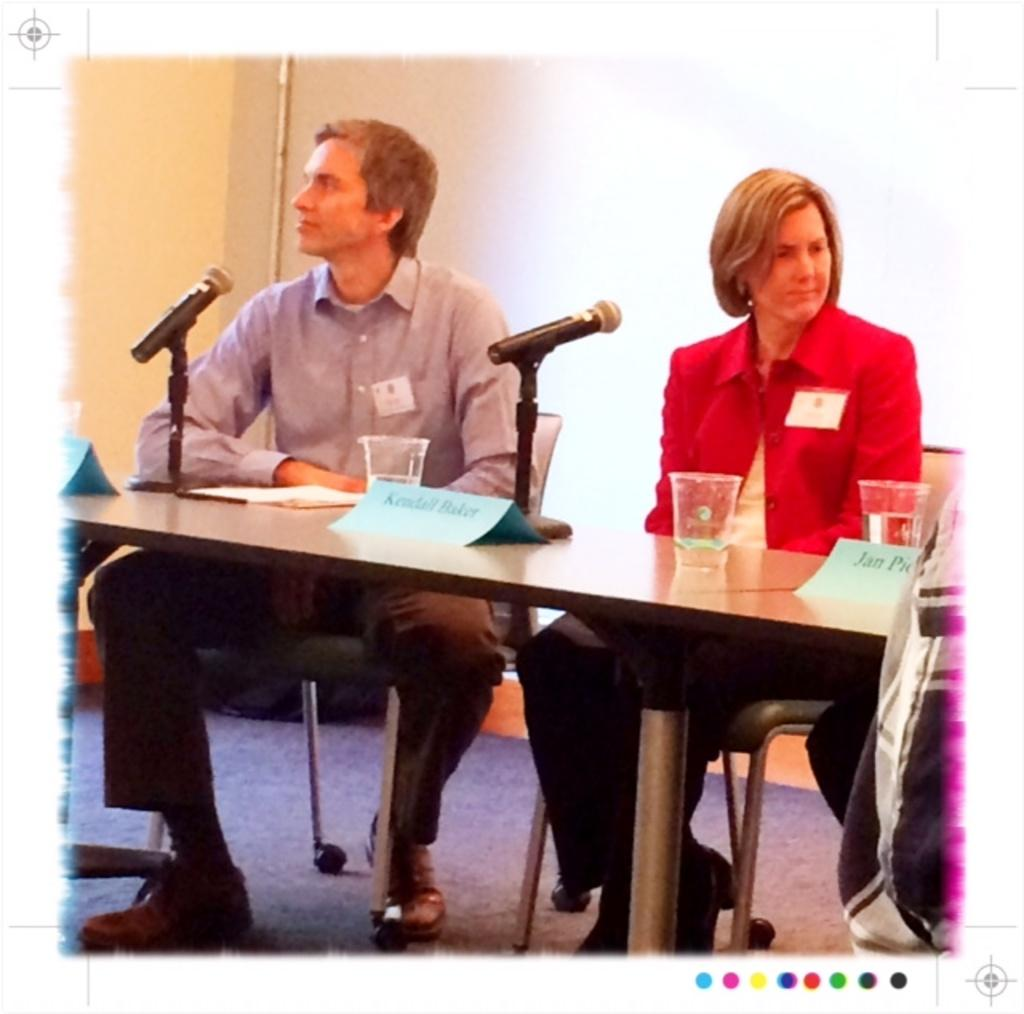Who can be seen in the image? There is a man and a woman in the image. What are the man and the woman doing in the image? They are seated on chairs and speaking using a microphone. What is present on the table in the image? There are glasses on a table in the image. What type of suit is the wren wearing in the image? There is no wren or suit present in the image. Can you tell me where the store is located in the image? There is no store present in the image. 